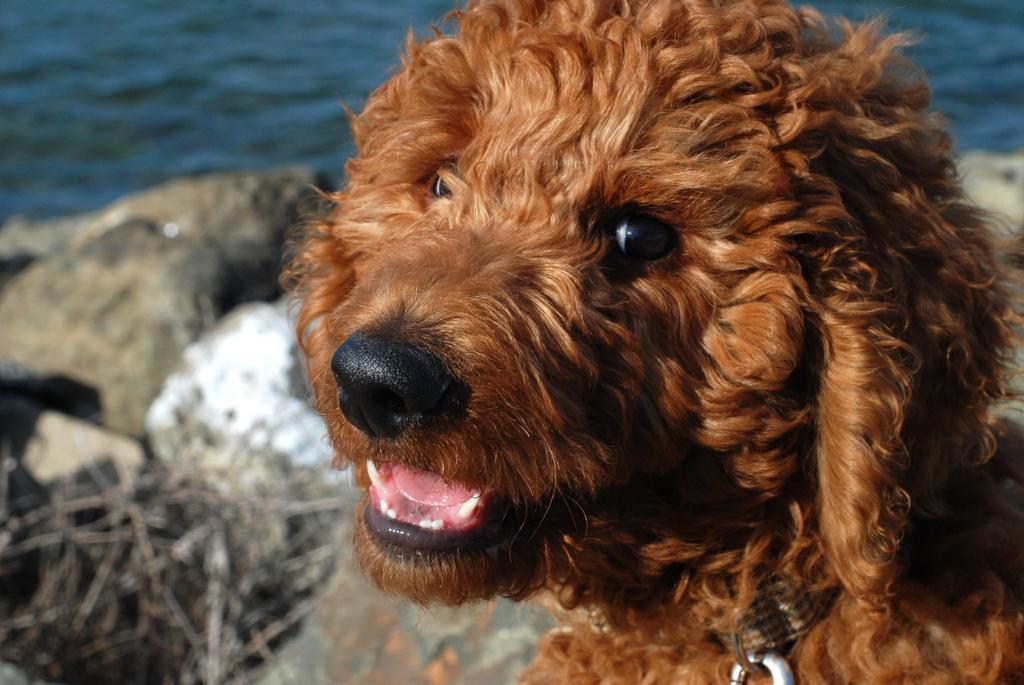Can you describe this image briefly? It is a dog in brown color. On the left side there is water. 